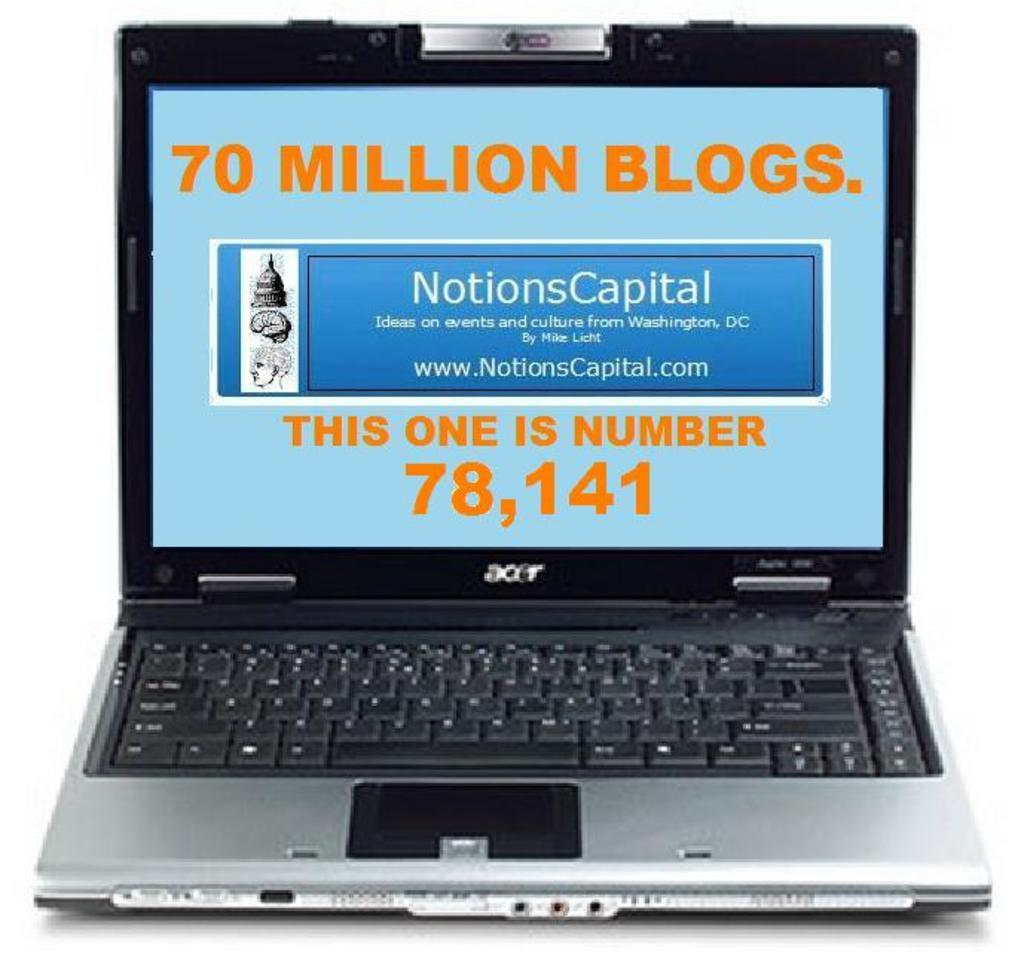<image>
Summarize the visual content of the image. Acer laptop that says 70 Million Blogs on the screen. 